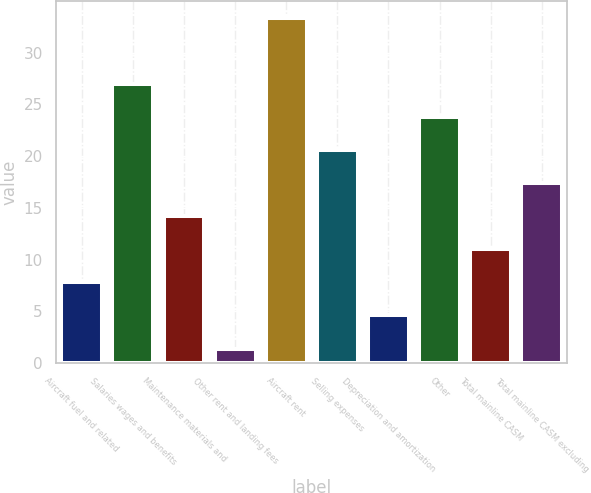Convert chart to OTSL. <chart><loc_0><loc_0><loc_500><loc_500><bar_chart><fcel>Aircraft fuel and related<fcel>Salaries wages and benefits<fcel>Maintenance materials and<fcel>Other rent and landing fees<fcel>Aircraft rent<fcel>Selling expenses<fcel>Depreciation and amortization<fcel>Other<fcel>Total mainline CASM<fcel>Total mainline CASM excluding<nl><fcel>7.78<fcel>26.92<fcel>14.16<fcel>1.4<fcel>33.3<fcel>20.54<fcel>4.59<fcel>23.73<fcel>10.97<fcel>17.35<nl></chart> 